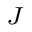<formula> <loc_0><loc_0><loc_500><loc_500>_ { J }</formula> 